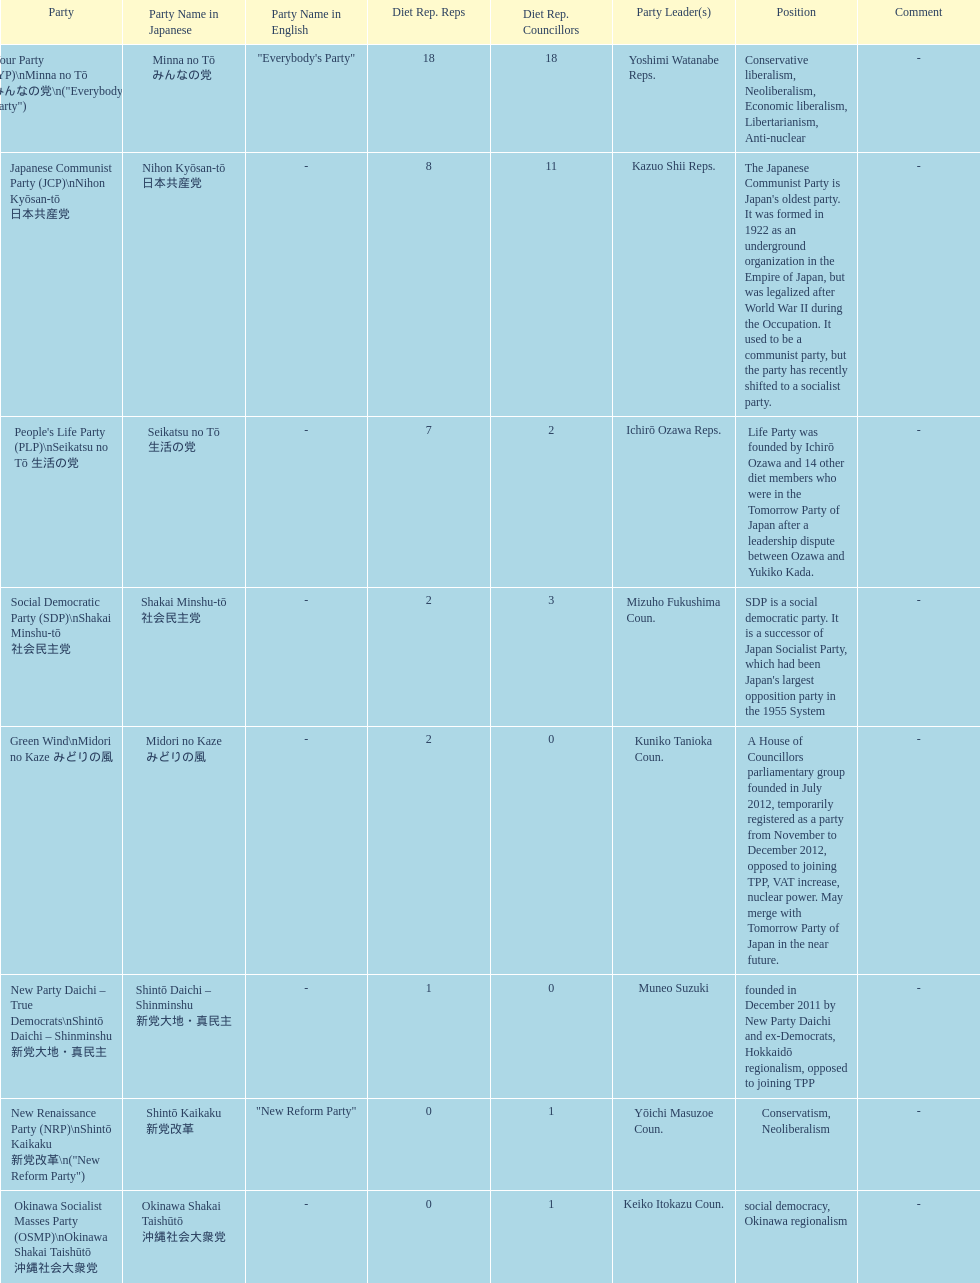According to this table, which party is japan's oldest political party? Japanese Communist Party (JCP) Nihon Kyōsan-tō 日本共産党. 